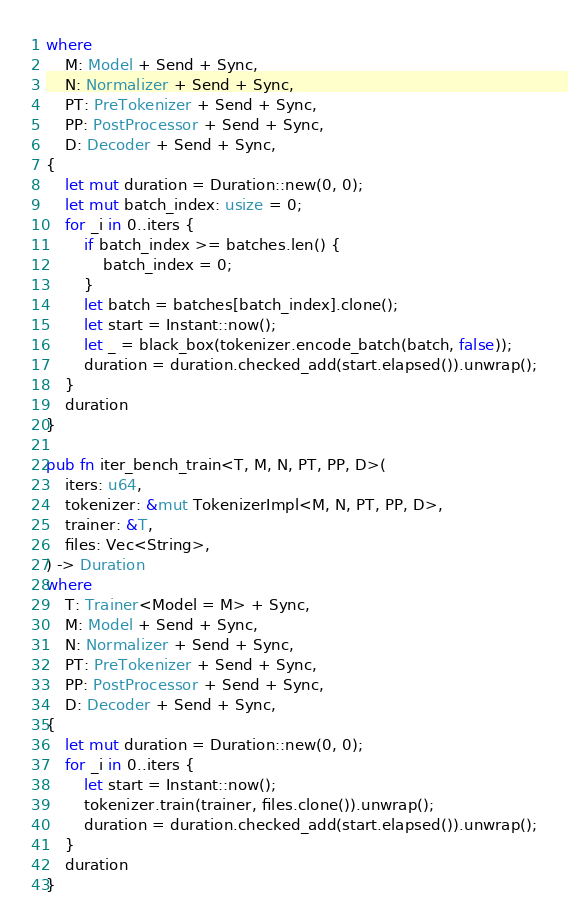Convert code to text. <code><loc_0><loc_0><loc_500><loc_500><_Rust_>where
    M: Model + Send + Sync,
    N: Normalizer + Send + Sync,
    PT: PreTokenizer + Send + Sync,
    PP: PostProcessor + Send + Sync,
    D: Decoder + Send + Sync,
{
    let mut duration = Duration::new(0, 0);
    let mut batch_index: usize = 0;
    for _i in 0..iters {
        if batch_index >= batches.len() {
            batch_index = 0;
        }
        let batch = batches[batch_index].clone();
        let start = Instant::now();
        let _ = black_box(tokenizer.encode_batch(batch, false));
        duration = duration.checked_add(start.elapsed()).unwrap();
    }
    duration
}

pub fn iter_bench_train<T, M, N, PT, PP, D>(
    iters: u64,
    tokenizer: &mut TokenizerImpl<M, N, PT, PP, D>,
    trainer: &T,
    files: Vec<String>,
) -> Duration
where
    T: Trainer<Model = M> + Sync,
    M: Model + Send + Sync,
    N: Normalizer + Send + Sync,
    PT: PreTokenizer + Send + Sync,
    PP: PostProcessor + Send + Sync,
    D: Decoder + Send + Sync,
{
    let mut duration = Duration::new(0, 0);
    for _i in 0..iters {
        let start = Instant::now();
        tokenizer.train(trainer, files.clone()).unwrap();
        duration = duration.checked_add(start.elapsed()).unwrap();
    }
    duration
}
</code> 